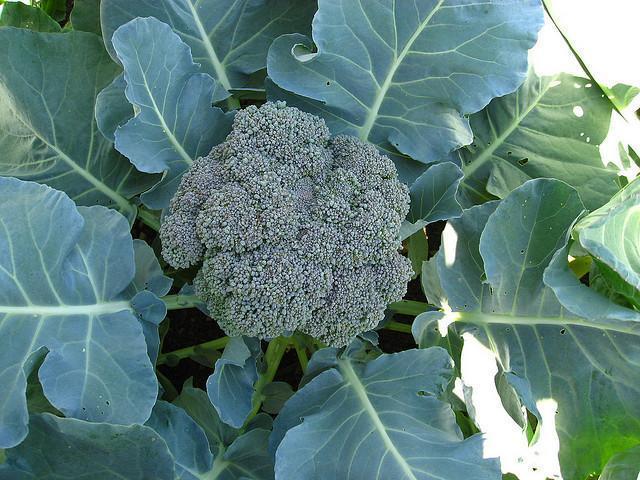How many leaves have water drops on them?
Give a very brief answer. 0. 